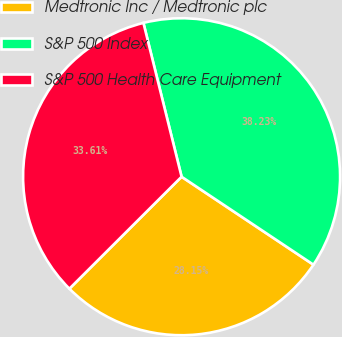Convert chart. <chart><loc_0><loc_0><loc_500><loc_500><pie_chart><fcel>Medtronic Inc / Medtronic plc<fcel>S&P 500 Index<fcel>S&P 500 Health Care Equipment<nl><fcel>28.15%<fcel>38.23%<fcel>33.61%<nl></chart> 